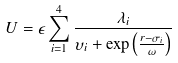<formula> <loc_0><loc_0><loc_500><loc_500>U = \epsilon \sum _ { i = 1 } ^ { 4 } \frac { \lambda _ { i } } { \upsilon _ { i } + \exp \left ( \frac { r - \sigma _ { i } } { \omega } \right ) }</formula> 